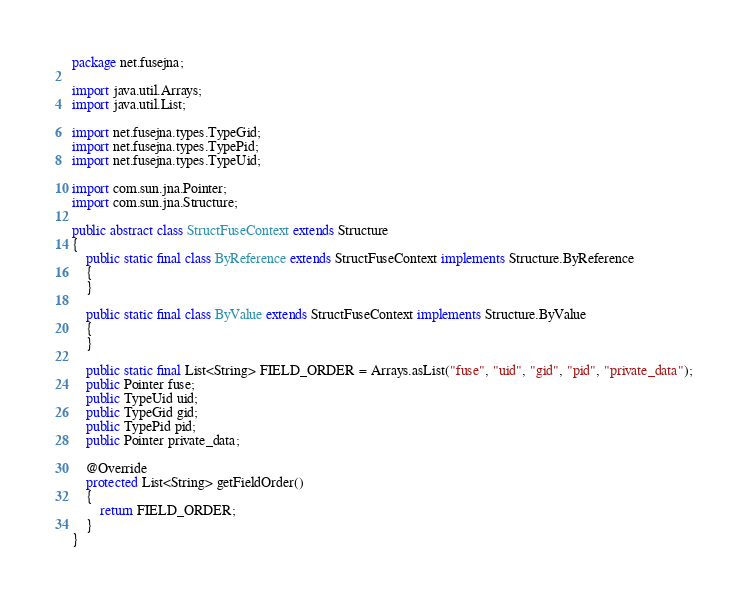<code> <loc_0><loc_0><loc_500><loc_500><_Java_>package net.fusejna;

import java.util.Arrays;
import java.util.List;

import net.fusejna.types.TypeGid;
import net.fusejna.types.TypePid;
import net.fusejna.types.TypeUid;

import com.sun.jna.Pointer;
import com.sun.jna.Structure;

public abstract class StructFuseContext extends Structure
{
	public static final class ByReference extends StructFuseContext implements Structure.ByReference
	{
	}

	public static final class ByValue extends StructFuseContext implements Structure.ByValue
	{
	}

	public static final List<String> FIELD_ORDER = Arrays.asList("fuse", "uid", "gid", "pid", "private_data");
	public Pointer fuse;
	public TypeUid uid;
	public TypeGid gid;
	public TypePid pid;
	public Pointer private_data;

	@Override
	protected List<String> getFieldOrder()
	{
		return FIELD_ORDER;
	}
}
</code> 